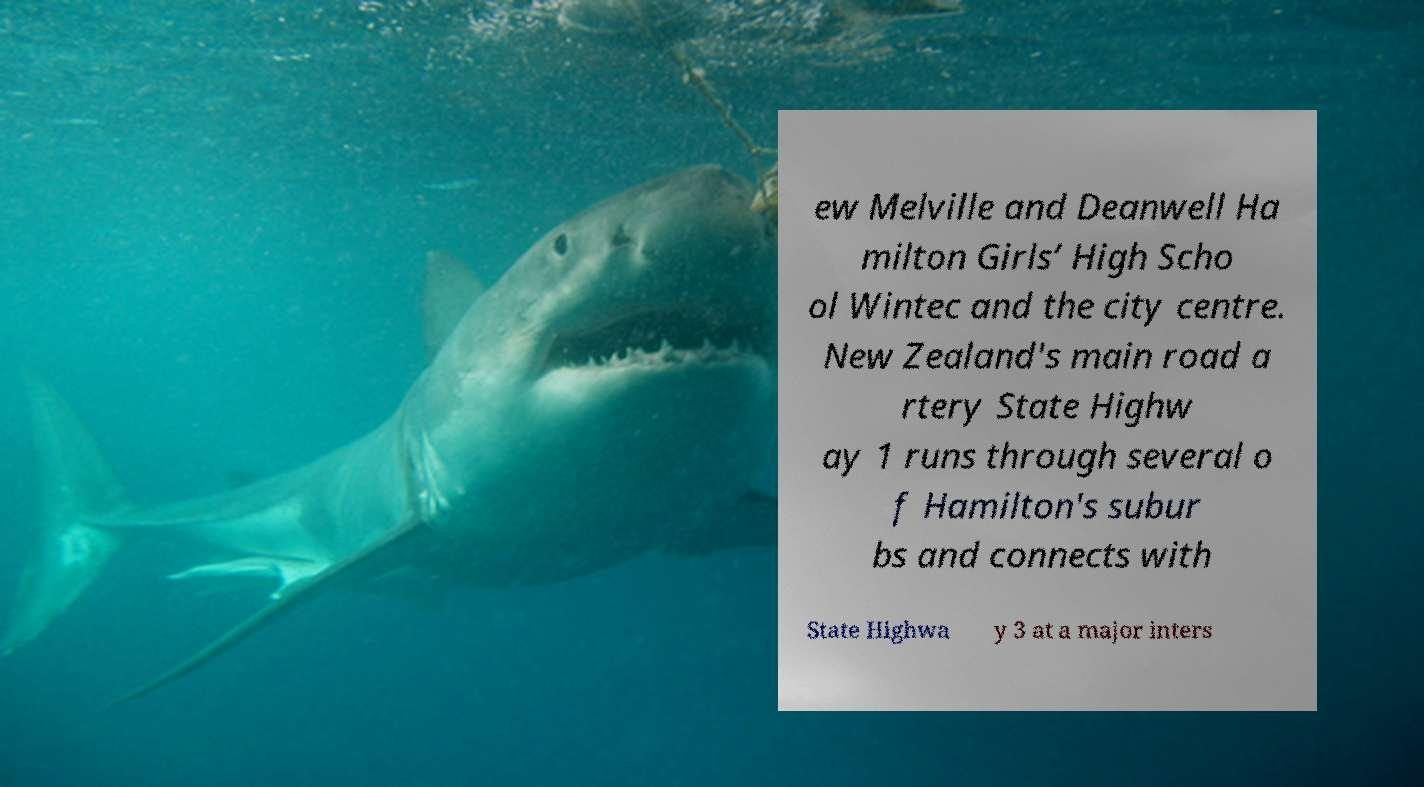Please read and relay the text visible in this image. What does it say? ew Melville and Deanwell Ha milton Girls’ High Scho ol Wintec and the city centre. New Zealand's main road a rtery State Highw ay 1 runs through several o f Hamilton's subur bs and connects with State Highwa y 3 at a major inters 